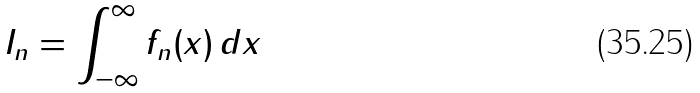Convert formula to latex. <formula><loc_0><loc_0><loc_500><loc_500>I _ { n } = \int _ { - \infty } ^ { \infty } f _ { n } ( x ) \, d x</formula> 